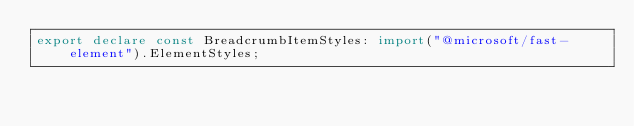Convert code to text. <code><loc_0><loc_0><loc_500><loc_500><_TypeScript_>export declare const BreadcrumbItemStyles: import("@microsoft/fast-element").ElementStyles;
</code> 